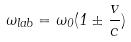<formula> <loc_0><loc_0><loc_500><loc_500>\omega _ { l a b } = \omega _ { 0 } ( 1 \pm \frac { v } { c } )</formula> 